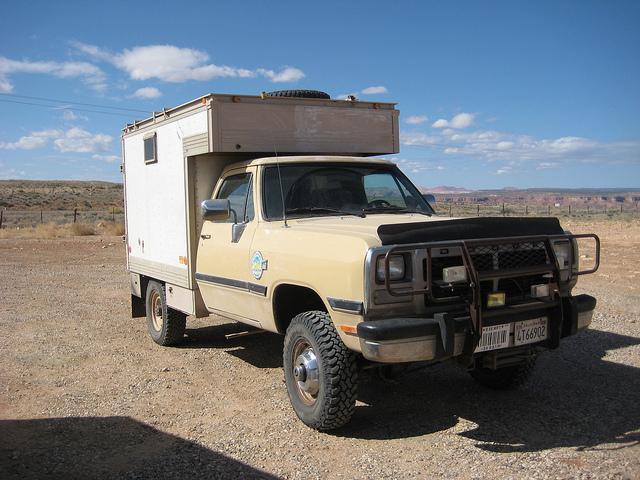Is there a bird sitting on the truck?
Keep it brief. No. Where truck is standing?
Answer briefly. Desert. What is in front of the truck?
Answer briefly. Grill. Is the truck on a road?
Answer briefly. No. What words are on the car's bumper plate?
Be succinct. Dodge. What does the license plate say?
Write a very short answer. 4t66902. 